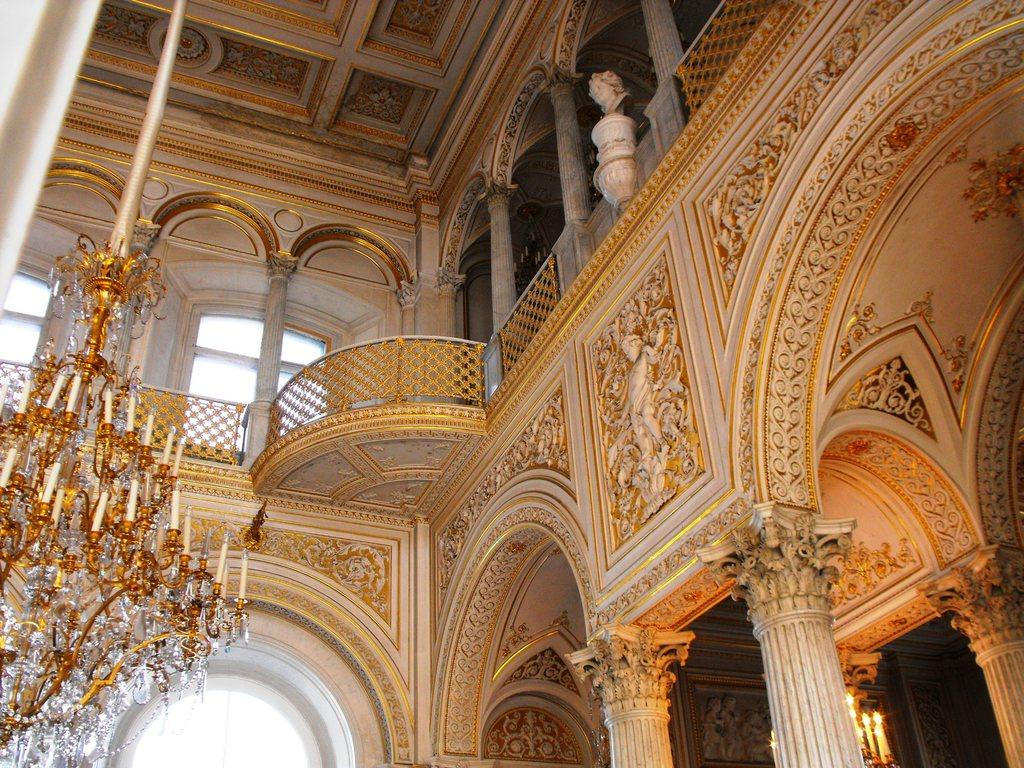What type of location is depicted in the image? The image is an inside picture of a building. What type of lighting fixture can be seen in the image? There is a chandelier in the image. What architectural features are present in the image? There are pillars in the image. What type of barrier is visible in the image? There is a fence in the image. What type of artwork is present in the image? There is a statue in the image. How are the walls decorated in the image? The walls in the image have a designed pattern. Can you see any poisonous plants near the statue in the image? There is no mention of any plants, poisonous or otherwise, in the image. The focus is on the chandelier, pillars, fence, and statue, as well as the designed wall patterns. 